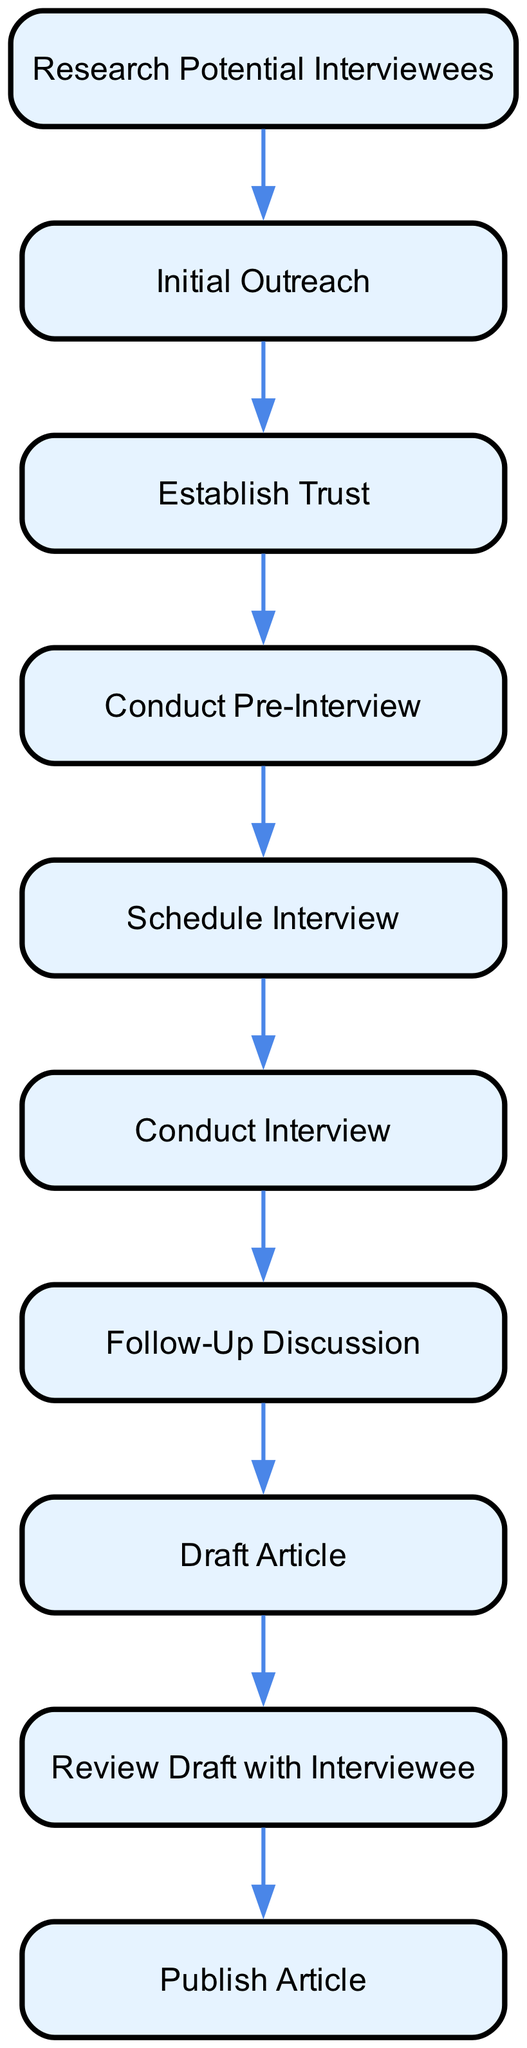What is the first step in the process? The first step in the process is indicated by the first node and is labeled "Research Potential Interviewees," which is the starting point of the flow.
Answer: Research Potential Interviewees How many nodes are there in total? Counting all the elements in the flow chart, there are ten distinct nodes presented in the process from start to finish.
Answer: 10 What follows after "Conduct Interview"? According to the flow, the step that follows "Conduct Interview" is "Follow-Up Discussion," which ensures continuity in the interview process.
Answer: Follow-Up Discussion What describes the purpose of “Establish Trust”? The purpose is about communicating openly regarding the aim of the interview and how the stories will be utilized, as described in the node's text.
Answer: Communicate openly Which two nodes are directly connected before “Draft Article”? Before reaching "Draft Article," the nodes "Follow-Up Discussion" and "Conduct Interview" are directly connected, forming a sequence prior to drafting the story.
Answer: Follow-Up Discussion, Conduct Interview What is the last step of the process? The last node in the sequence represents the final action to be taken in the process, which is "Publish Article," indicating the conclusion of the interviewing journey.
Answer: Publish Article What is the relationship between "Initial Outreach" and "Establish Trust"? "Initial Outreach" leads to "Establish Trust," where initial contact is made to establish a foundation of trust before proceeding further in the process.
Answer: Initial Outreach → Establish Trust What step directly comes before "Review Draft with Interviewee"? Before "Review Draft with Interviewee," the step that comes directly prior is "Draft Article," indicating that the draft requires review after its creation.
Answer: Draft Article What is a key theme emphasized in the "Draft Article"? The key theme in the "Draft Article" is to emphasize the interviewee's voice and perspective, reflecting their individual experiences and stories in the article.
Answer: Interviewee's voice and perspective 